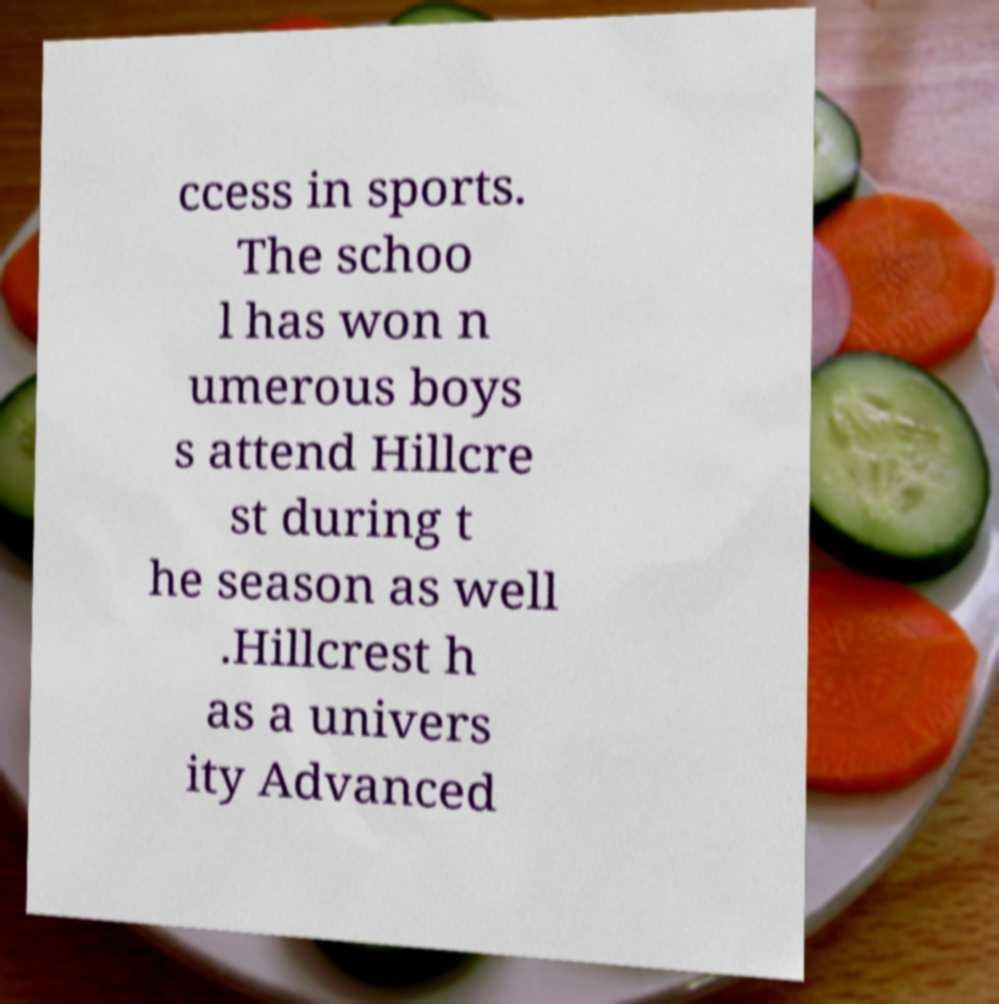What messages or text are displayed in this image? I need them in a readable, typed format. ccess in sports. The schoo l has won n umerous boys s attend Hillcre st during t he season as well .Hillcrest h as a univers ity Advanced 